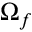Convert formula to latex. <formula><loc_0><loc_0><loc_500><loc_500>\Omega _ { f }</formula> 